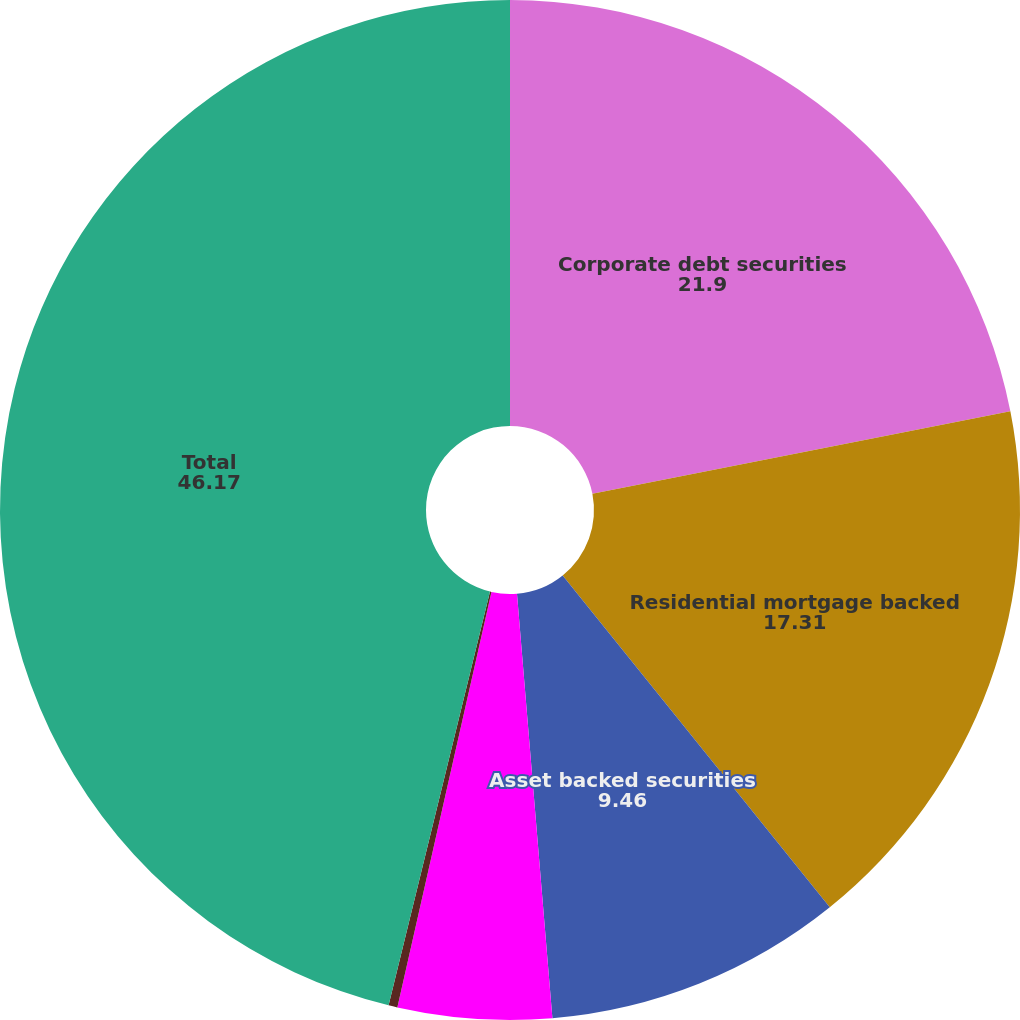Convert chart to OTSL. <chart><loc_0><loc_0><loc_500><loc_500><pie_chart><fcel>Corporate debt securities<fcel>Residential mortgage backed<fcel>Asset backed securities<fcel>State and municipal<fcel>Foreign government bonds and<fcel>Total<nl><fcel>21.9%<fcel>17.31%<fcel>9.46%<fcel>4.87%<fcel>0.28%<fcel>46.17%<nl></chart> 